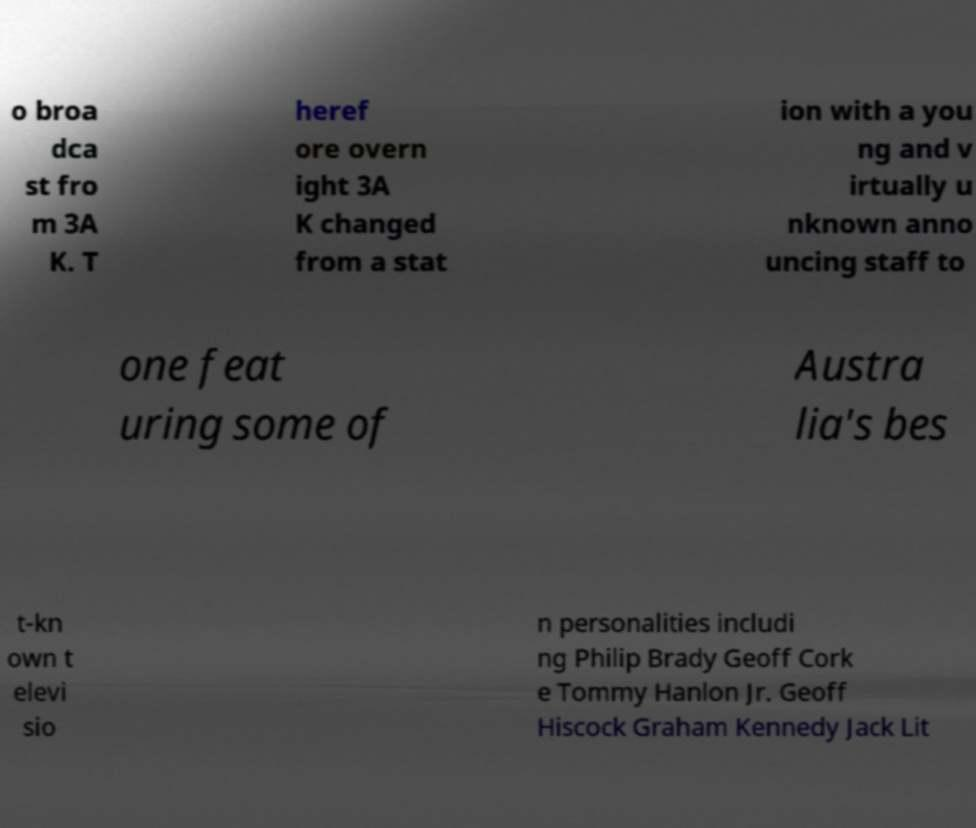Please identify and transcribe the text found in this image. o broa dca st fro m 3A K. T heref ore overn ight 3A K changed from a stat ion with a you ng and v irtually u nknown anno uncing staff to one feat uring some of Austra lia's bes t-kn own t elevi sio n personalities includi ng Philip Brady Geoff Cork e Tommy Hanlon Jr. Geoff Hiscock Graham Kennedy Jack Lit 